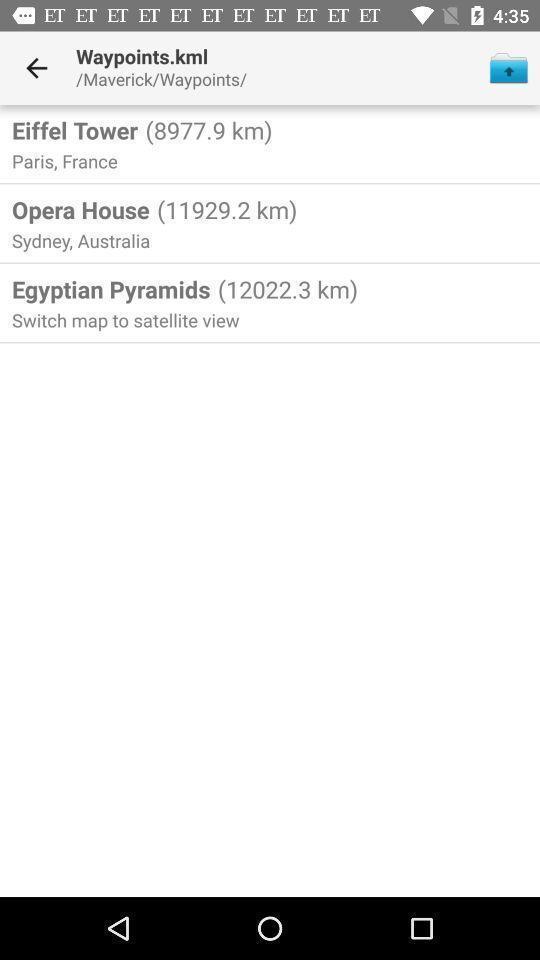Explain what's happening in this screen capture. Screen shows locations list in the maps application. 